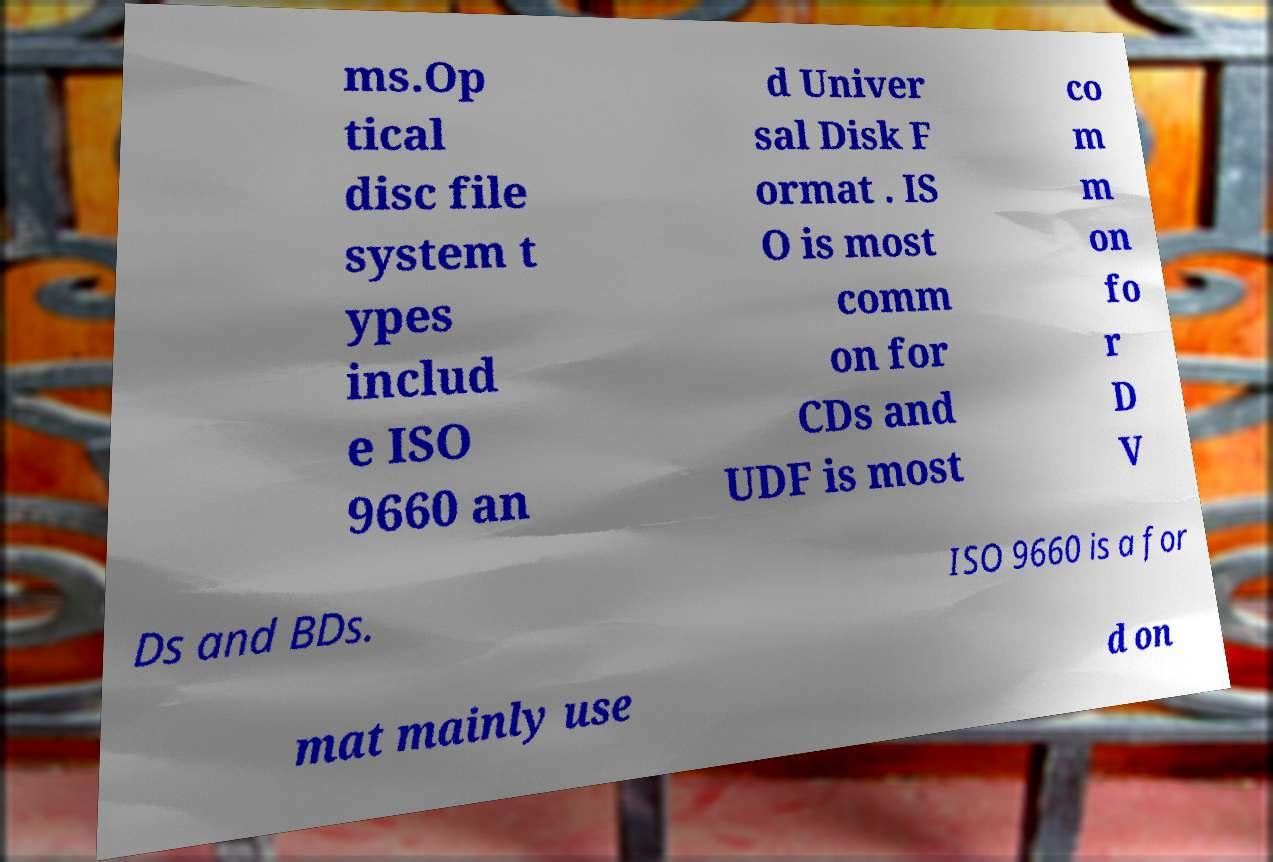Please identify and transcribe the text found in this image. ms.Op tical disc file system t ypes includ e ISO 9660 an d Univer sal Disk F ormat . IS O is most comm on for CDs and UDF is most co m m on fo r D V Ds and BDs. ISO 9660 is a for mat mainly use d on 